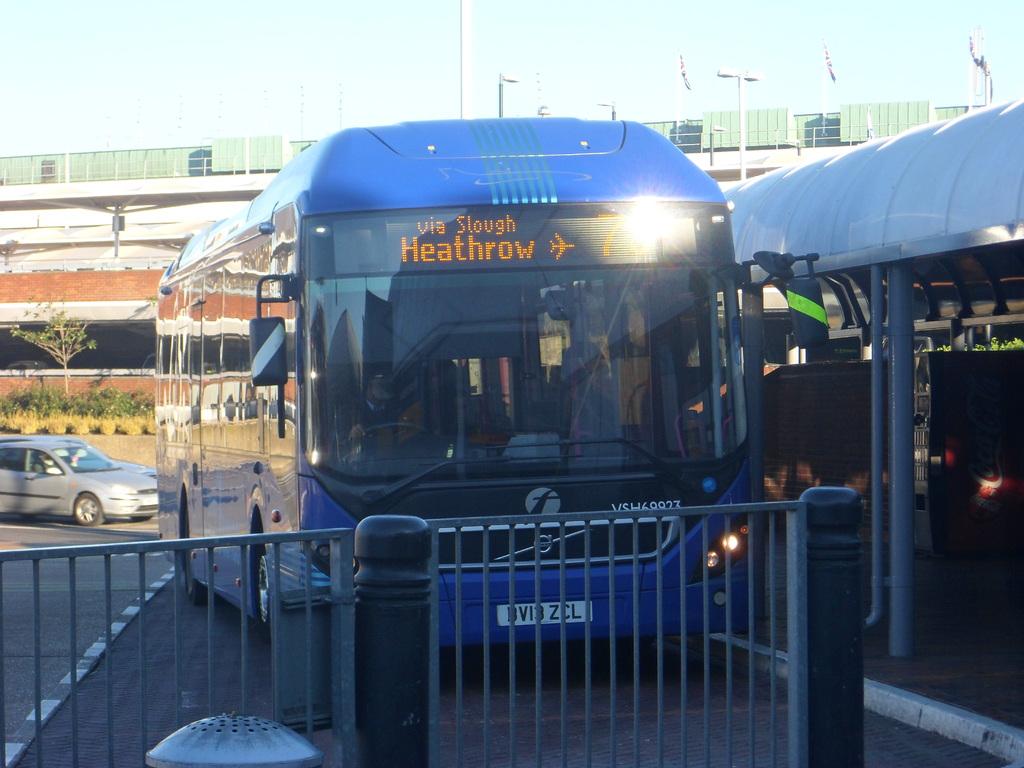Where is this bus going?
Keep it short and to the point. Heathrow. Where is this bus coming from?
Ensure brevity in your answer.  Heathrow. 